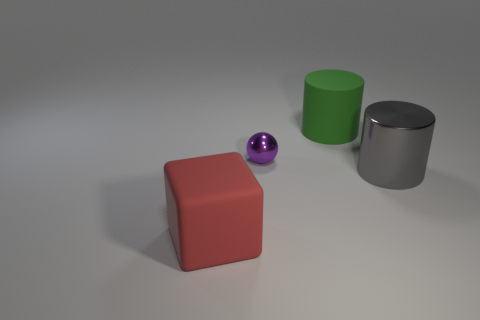Subtract all gray cylinders. How many cylinders are left? 1 Subtract 0 green blocks. How many objects are left? 4 Subtract all cubes. How many objects are left? 3 Subtract 2 cylinders. How many cylinders are left? 0 Subtract all green balls. Subtract all purple cylinders. How many balls are left? 1 Subtract all gray cylinders. How many green cubes are left? 0 Subtract all large gray cylinders. Subtract all green objects. How many objects are left? 2 Add 2 rubber cylinders. How many rubber cylinders are left? 3 Add 3 big cylinders. How many big cylinders exist? 5 Add 4 brown matte spheres. How many objects exist? 8 